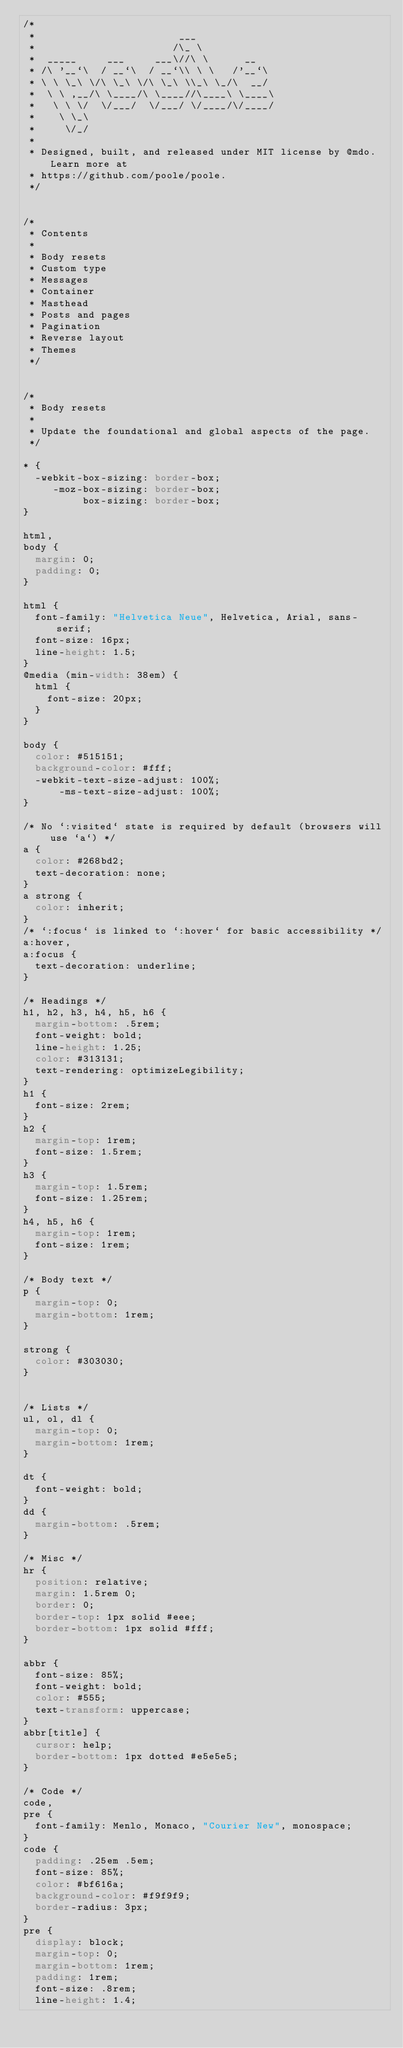Convert code to text. <code><loc_0><loc_0><loc_500><loc_500><_CSS_>/*
 *                        ___
 *                       /\_ \
 *  _____     ___     ___\//\ \      __
 * /\ '__`\  / __`\  / __`\\ \ \   /'__`\
 * \ \ \_\ \/\ \_\ \/\ \_\ \\_\ \_/\  __/
 *  \ \ ,__/\ \____/\ \____//\____\ \____\
 *   \ \ \/  \/___/  \/___/ \/____/\/____/
 *    \ \_\
 *     \/_/
 *
 * Designed, built, and released under MIT license by @mdo. Learn more at
 * https://github.com/poole/poole.
 */


/*
 * Contents
 *
 * Body resets
 * Custom type
 * Messages
 * Container
 * Masthead
 * Posts and pages
 * Pagination
 * Reverse layout
 * Themes
 */


/*
 * Body resets
 *
 * Update the foundational and global aspects of the page.
 */

* {
  -webkit-box-sizing: border-box;
     -moz-box-sizing: border-box;
          box-sizing: border-box;
}

html,
body {
  margin: 0;
  padding: 0;
}

html {
  font-family: "Helvetica Neue", Helvetica, Arial, sans-serif;
  font-size: 16px;
  line-height: 1.5;
}
@media (min-width: 38em) {
  html {
    font-size: 20px;
  }
}

body {
  color: #515151;
  background-color: #fff;
  -webkit-text-size-adjust: 100%;
      -ms-text-size-adjust: 100%;
}

/* No `:visited` state is required by default (browsers will use `a`) */
a {
  color: #268bd2;
  text-decoration: none;
}
a strong {
  color: inherit;
}
/* `:focus` is linked to `:hover` for basic accessibility */
a:hover,
a:focus {
  text-decoration: underline;
}

/* Headings */
h1, h2, h3, h4, h5, h6 {
  margin-bottom: .5rem;
  font-weight: bold;
  line-height: 1.25;
  color: #313131;
  text-rendering: optimizeLegibility;
}
h1 {
  font-size: 2rem;
}
h2 {
  margin-top: 1rem;
  font-size: 1.5rem;
}
h3 {
  margin-top: 1.5rem;
  font-size: 1.25rem;
}
h4, h5, h6 {
  margin-top: 1rem;
  font-size: 1rem;
}

/* Body text */
p {
  margin-top: 0;
  margin-bottom: 1rem;
}

strong {
  color: #303030;
}


/* Lists */
ul, ol, dl {
  margin-top: 0;
  margin-bottom: 1rem;
}

dt {
  font-weight: bold;
}
dd {
  margin-bottom: .5rem;
}

/* Misc */
hr {
  position: relative;
  margin: 1.5rem 0;
  border: 0;
  border-top: 1px solid #eee;
  border-bottom: 1px solid #fff;
}

abbr {
  font-size: 85%;
  font-weight: bold;
  color: #555;
  text-transform: uppercase;
}
abbr[title] {
  cursor: help;
  border-bottom: 1px dotted #e5e5e5;
}

/* Code */
code,
pre {
  font-family: Menlo, Monaco, "Courier New", monospace;
}
code {
  padding: .25em .5em;
  font-size: 85%;
  color: #bf616a;
  background-color: #f9f9f9;
  border-radius: 3px;
}
pre {
  display: block;
  margin-top: 0;
  margin-bottom: 1rem;
  padding: 1rem;
  font-size: .8rem;
  line-height: 1.4;</code> 